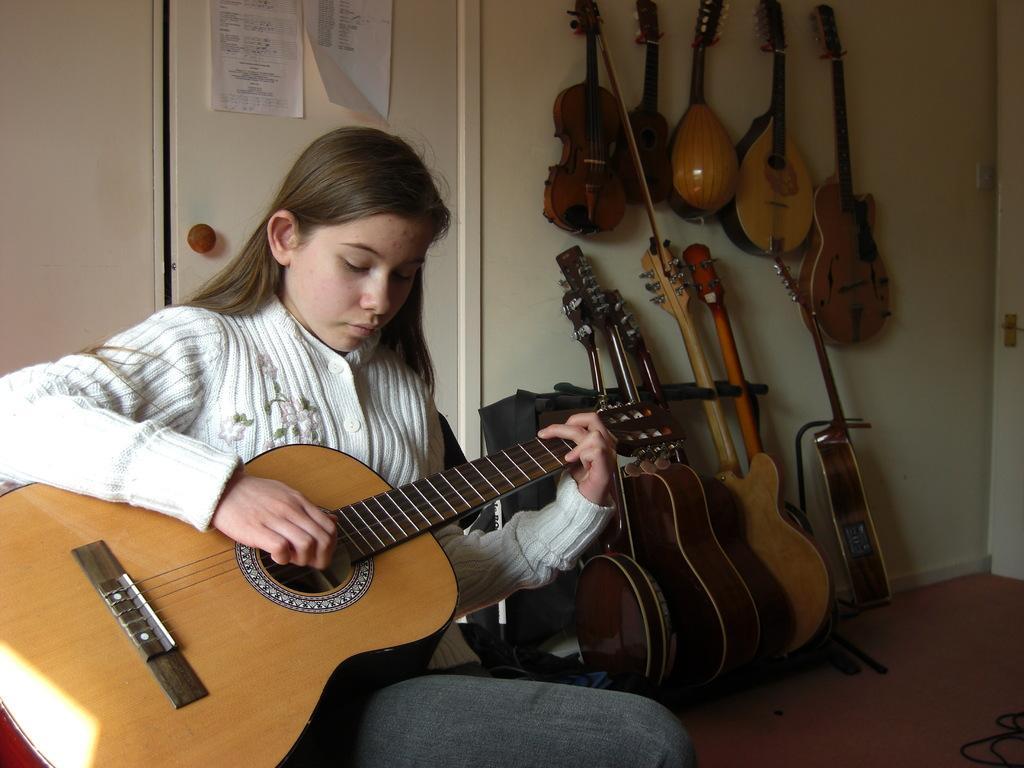How would you summarize this image in a sentence or two? In this image a girl is sitting and playing a guitar holding in her hand. At the right side there are musical instruments on the floor and also on the wall hanging. In the background on the door there are two papers attached. At the right side on the floor there are some wires. 